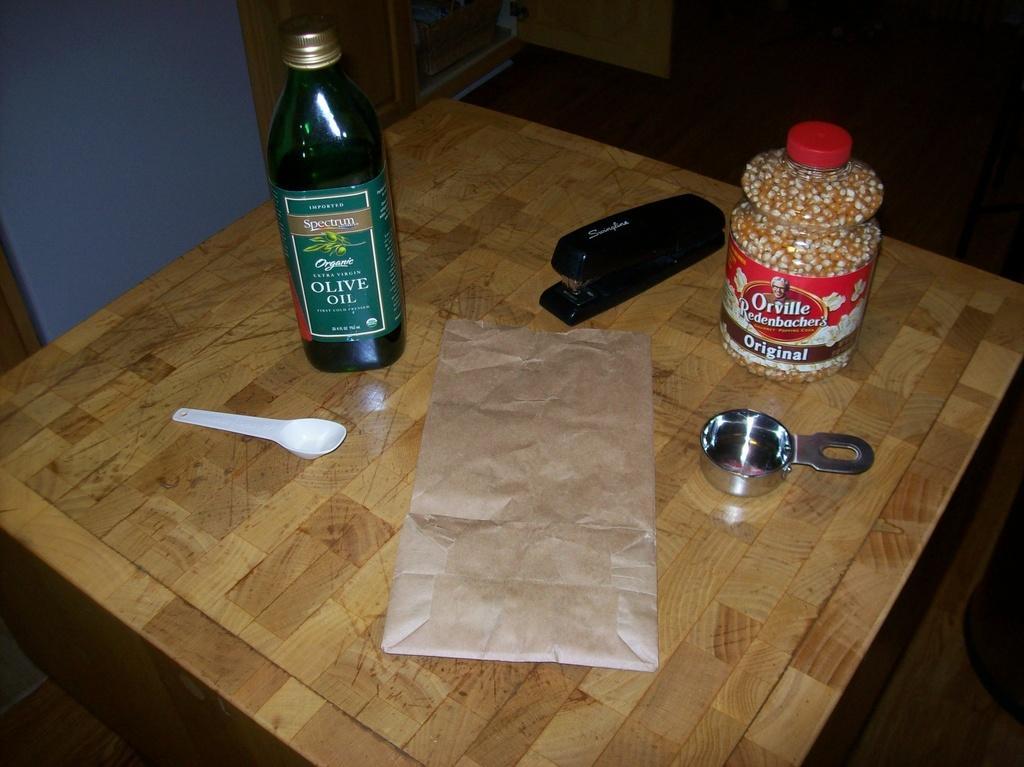Could you give a brief overview of what you see in this image? In this image I can see bottle,spoon and some of the objects on the table. 